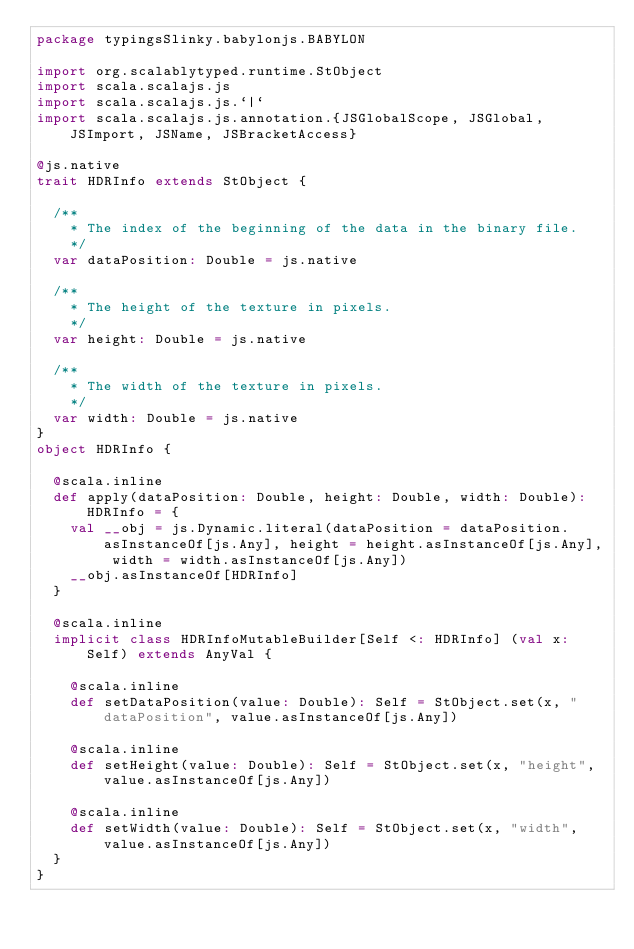<code> <loc_0><loc_0><loc_500><loc_500><_Scala_>package typingsSlinky.babylonjs.BABYLON

import org.scalablytyped.runtime.StObject
import scala.scalajs.js
import scala.scalajs.js.`|`
import scala.scalajs.js.annotation.{JSGlobalScope, JSGlobal, JSImport, JSName, JSBracketAccess}

@js.native
trait HDRInfo extends StObject {
  
  /**
    * The index of the beginning of the data in the binary file.
    */
  var dataPosition: Double = js.native
  
  /**
    * The height of the texture in pixels.
    */
  var height: Double = js.native
  
  /**
    * The width of the texture in pixels.
    */
  var width: Double = js.native
}
object HDRInfo {
  
  @scala.inline
  def apply(dataPosition: Double, height: Double, width: Double): HDRInfo = {
    val __obj = js.Dynamic.literal(dataPosition = dataPosition.asInstanceOf[js.Any], height = height.asInstanceOf[js.Any], width = width.asInstanceOf[js.Any])
    __obj.asInstanceOf[HDRInfo]
  }
  
  @scala.inline
  implicit class HDRInfoMutableBuilder[Self <: HDRInfo] (val x: Self) extends AnyVal {
    
    @scala.inline
    def setDataPosition(value: Double): Self = StObject.set(x, "dataPosition", value.asInstanceOf[js.Any])
    
    @scala.inline
    def setHeight(value: Double): Self = StObject.set(x, "height", value.asInstanceOf[js.Any])
    
    @scala.inline
    def setWidth(value: Double): Self = StObject.set(x, "width", value.asInstanceOf[js.Any])
  }
}
</code> 